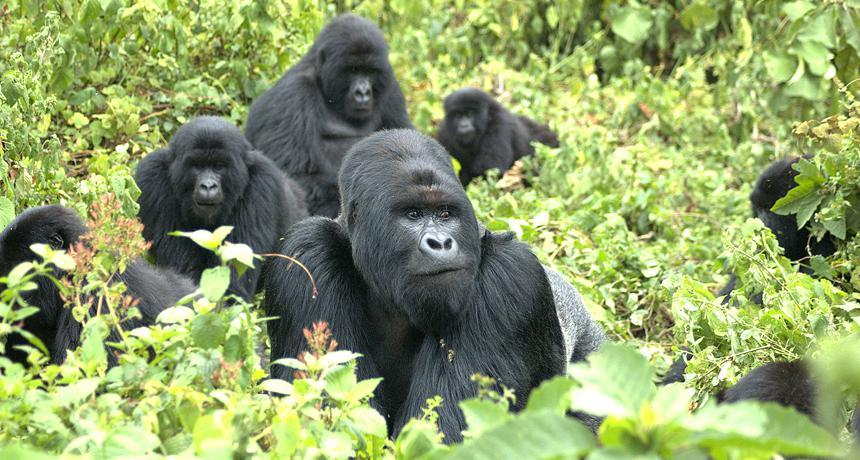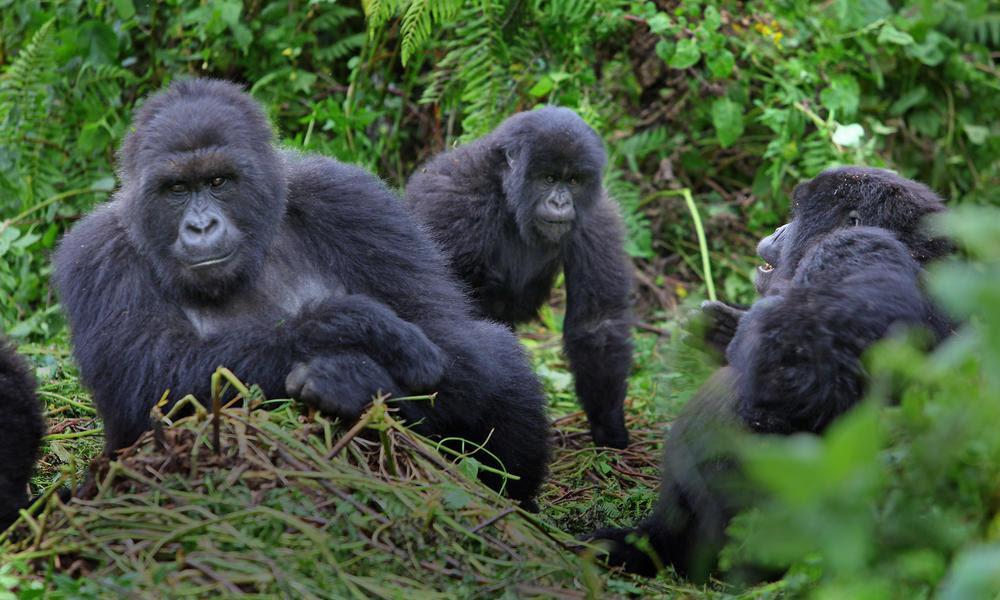The first image is the image on the left, the second image is the image on the right. Analyze the images presented: Is the assertion "The gorilla in the foreground of the right image has both its hands at mouth level, with fingers curled." valid? Answer yes or no. No. The first image is the image on the left, the second image is the image on the right. Considering the images on both sides, is "There is a group of gorillas in both images." valid? Answer yes or no. Yes. 